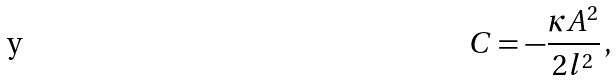Convert formula to latex. <formula><loc_0><loc_0><loc_500><loc_500>C = - \frac { \kappa A ^ { 2 } } { 2 l ^ { 2 } } \, ,</formula> 